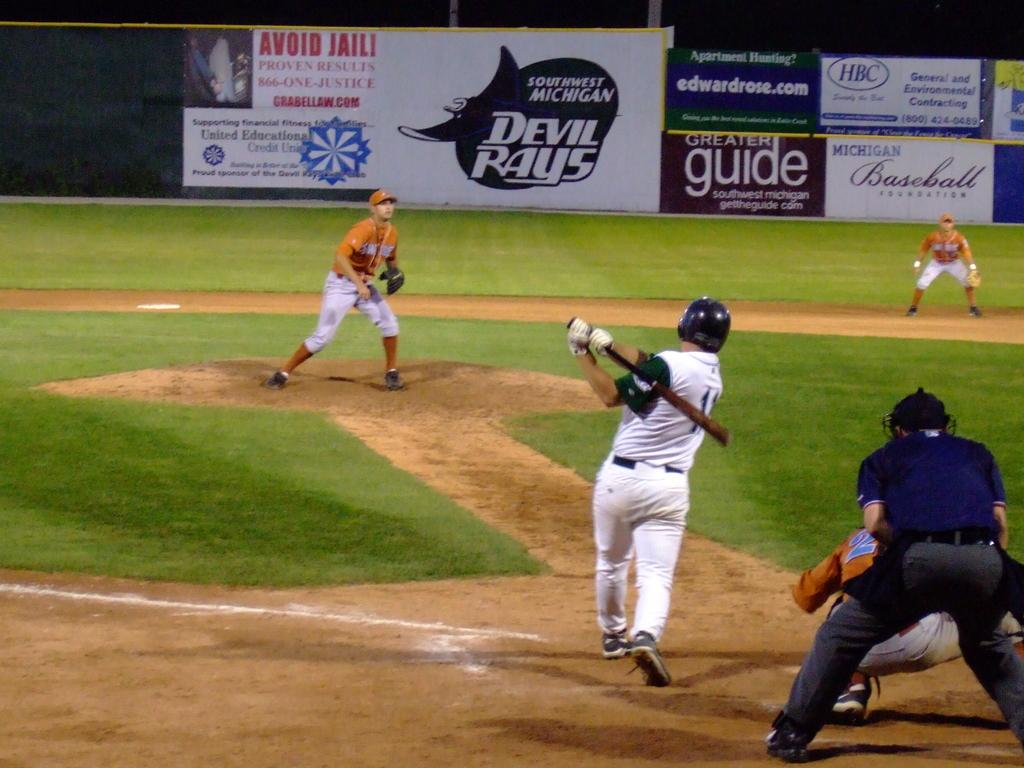<image>
Offer a succinct explanation of the picture presented. The Southwest Michigan Devil Rays play baseball in a stadium. 